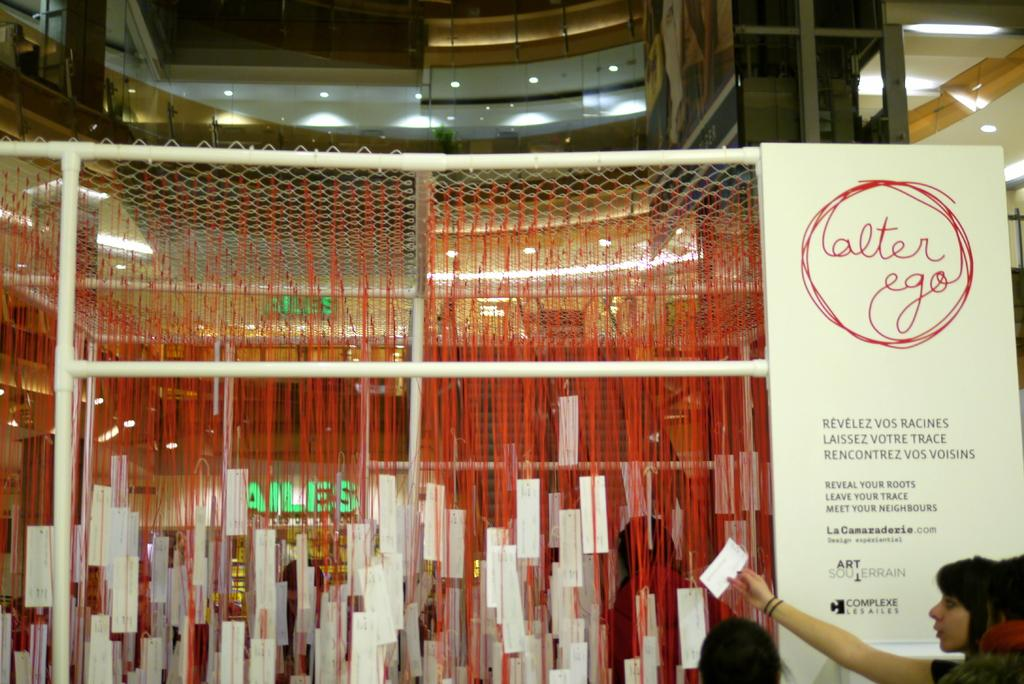How many people are in the group visible in the image? There is a group of people in the image, but the exact number cannot be determined from the provided facts. What is the hoarding advertising in the image? The provided facts do not mention the content of the hoarding. What are the metal rods used for in the image? The purpose of the metal rods in the image cannot be determined from the provided facts. What is the net used for in the image? The purpose of the net in the image cannot be determined from the provided facts. What type of papers are present in the image? The provided facts do not specify the type of papers in the image. What kind of lights are visible in the background of the image? The provided facts do not specify the type of lights in the background. What can be seen in the background of the image besides the lights? There are buildings visible in the background of the image. Who is making the payment for the parcel in the image? There is no mention of a parcel or payment in the provided facts, so this question cannot be answered. 